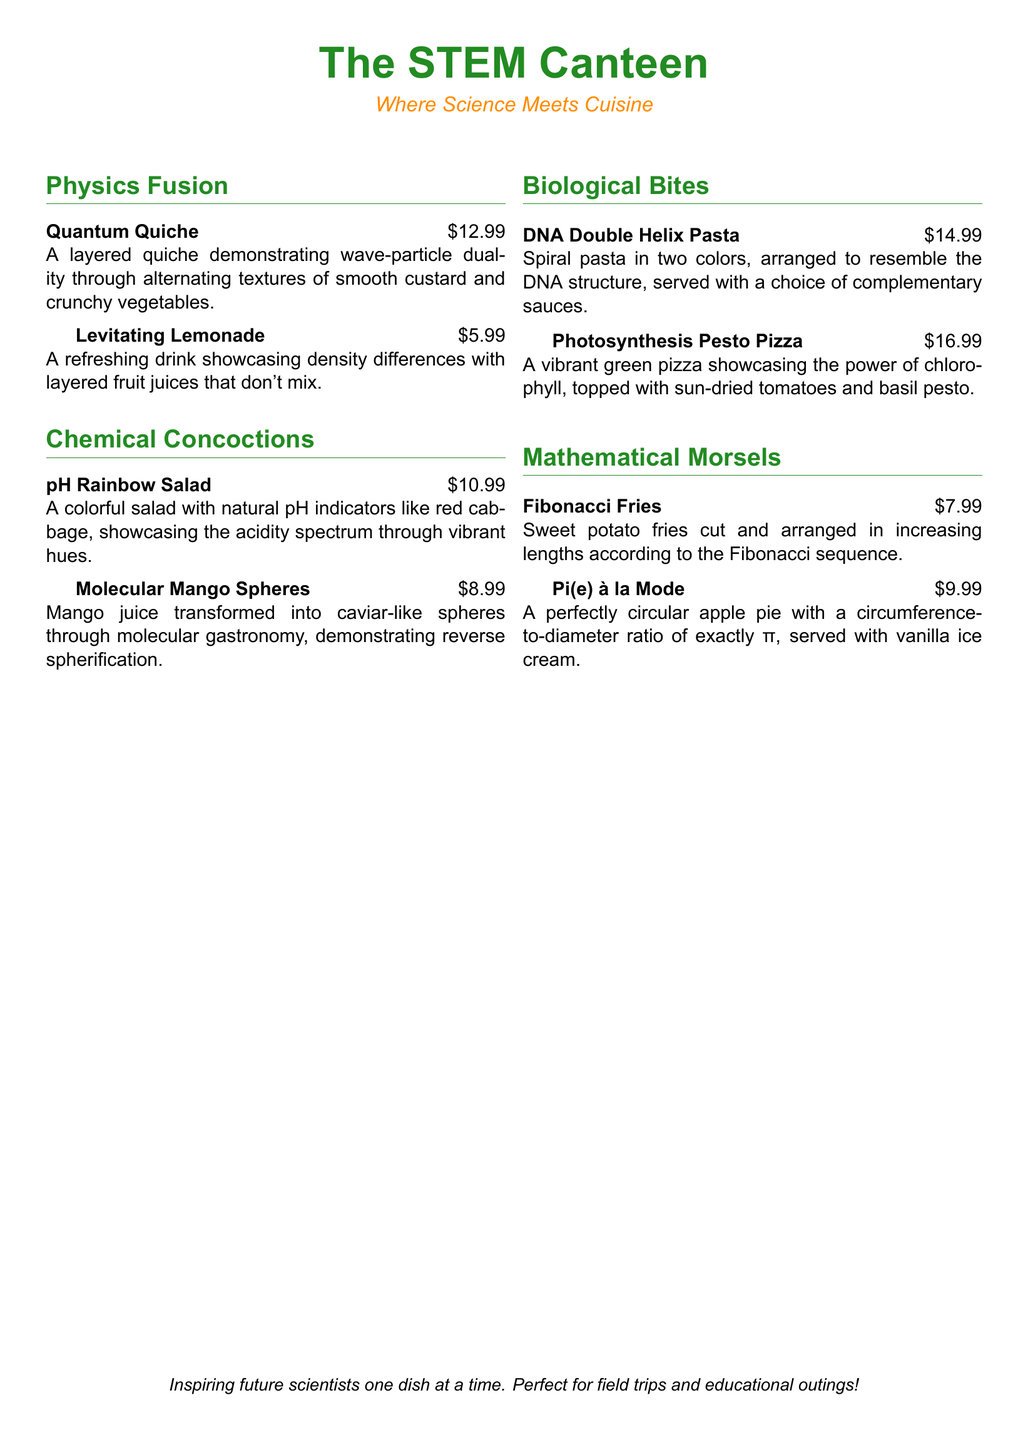What is the title of the menu? The title of the menu is prominently displayed at the top of the document.
Answer: The STEM Canteen What is the price of Quantum Quiche? The menu lists the price of Quantum Quiche next to its description.
Answer: $12.99 What dish showcases density differences? The description explains how layering juice demonstrates this scientific principle.
Answer: Levitating Lemonade Which salad uses natural pH indicators? The menu specifies that the salad incorporates certain natural pH indicators.
Answer: pH Rainbow Salad What is the theme of the menu? The subtitle under the title conveys the overall theme of the establishment.
Answer: Where Science Meets Cuisine How much do Fibonacci Fries cost? The price for Fibonacci Fries is indicated in the menu.
Answer: $7.99 Which dish represents the Fibonacci sequence? The description notes that the dish is arranged according to a specific numerical sequence.
Answer: Fibonacci Fries What color is the DNA Double Helix Pasta? The document describes the colors of the pasta used in the dish.
Answer: Two colors What type of pizza is featured on the menu? The menu provides the name of the pizza dish, which is tied to a biological concept.
Answer: Photosynthesis Pesto Pizza How is Pi(e) à la Mode served? The menu indicates how this dish is presented alongside another item.
Answer: With vanilla ice cream 